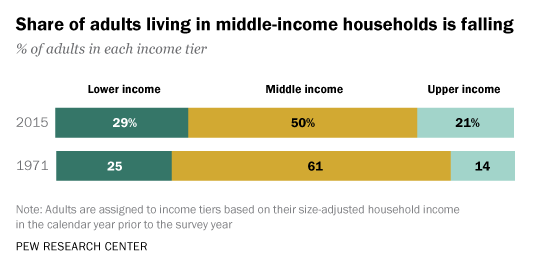Give some essential details in this illustration. The share of the middle-class changed by 0.11% from 1971 to 2015. In 1971, the value of the middle-income share was 0.61... 